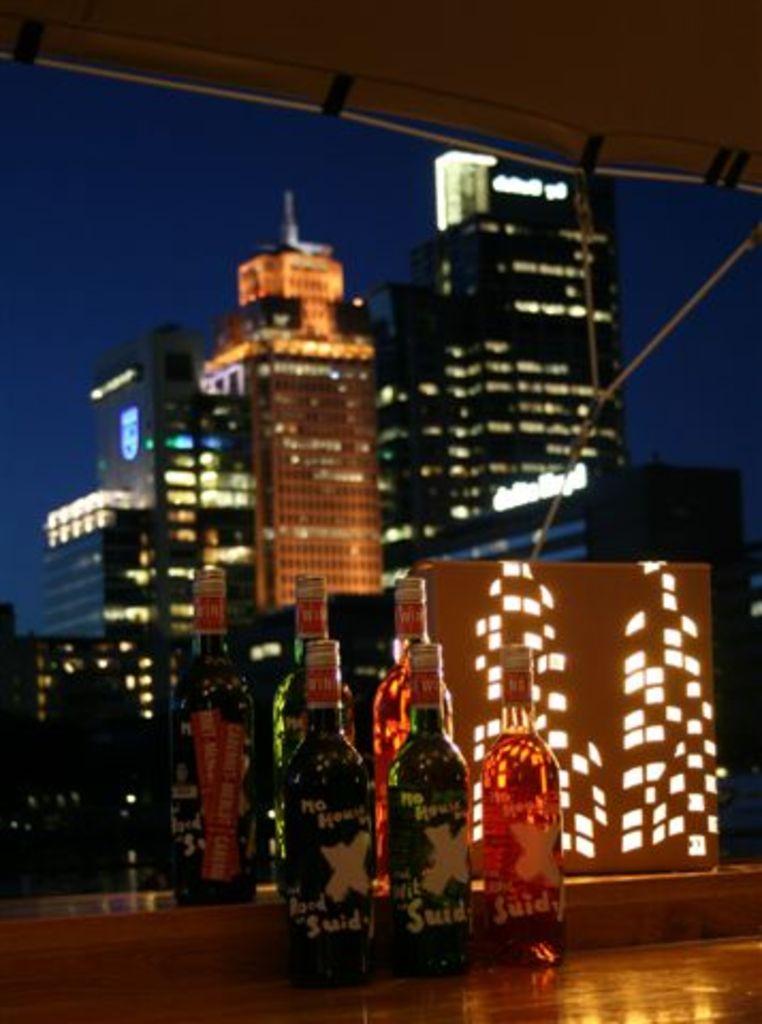Is it morning or night?
Your answer should be very brief. Answering does not require reading text in the image. 